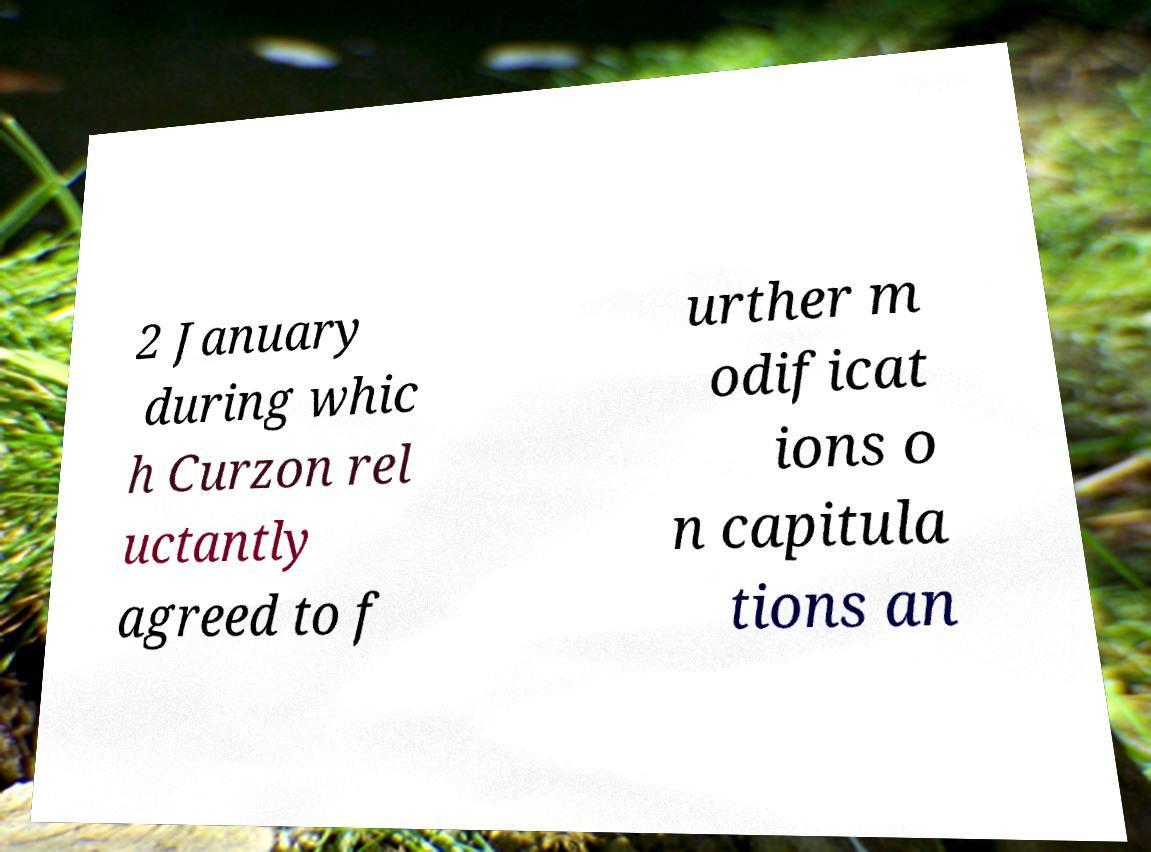Can you read and provide the text displayed in the image?This photo seems to have some interesting text. Can you extract and type it out for me? 2 January during whic h Curzon rel uctantly agreed to f urther m odificat ions o n capitula tions an 